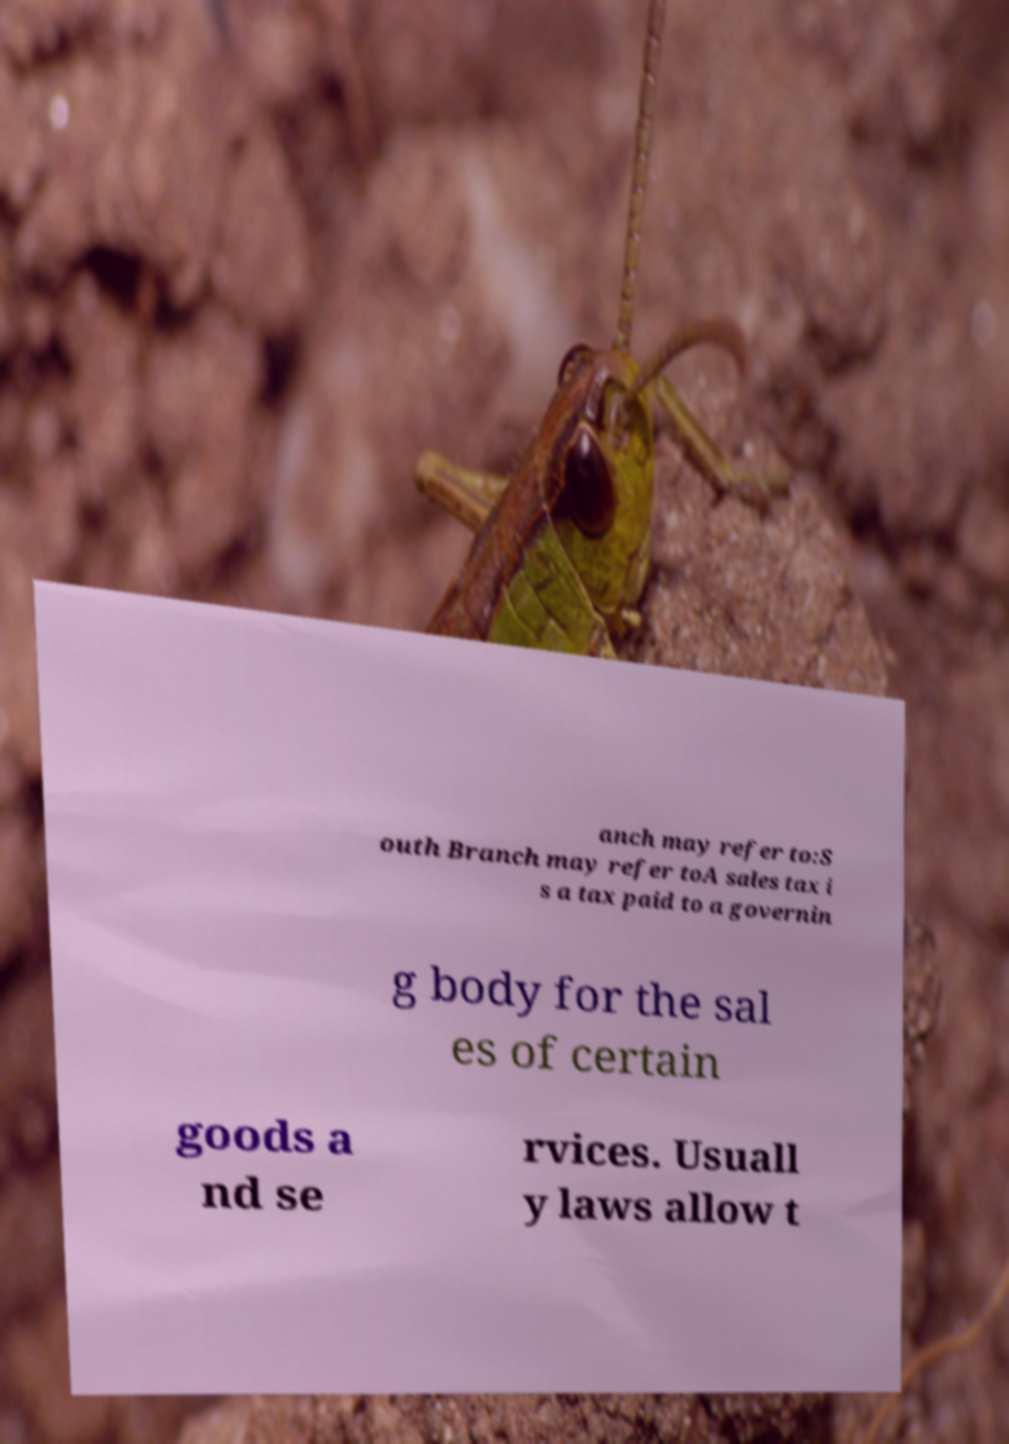Could you assist in decoding the text presented in this image and type it out clearly? anch may refer to:S outh Branch may refer toA sales tax i s a tax paid to a governin g body for the sal es of certain goods a nd se rvices. Usuall y laws allow t 